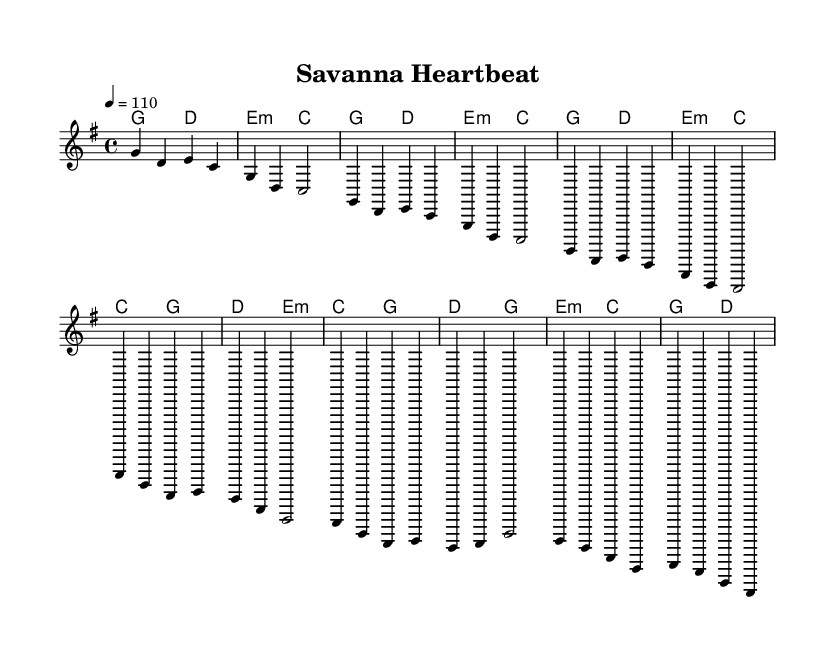What is the key signature of this music? The key signature is G major, which has one sharp (F#).
Answer: G major What is the time signature of this music? The time signature is 4/4, indicating four beats per measure.
Answer: 4/4 What is the tempo marking of this piece? The tempo marking is 110 beats per minute, indicated by the number under the tempo command.
Answer: 110 Which chord occurs most frequently in the harmonies? By analyzing the harmony section, G major appears at the start of multiple measures, making it prominent.
Answer: G major How many measures does the chorus section contain? The chorus consists of four measures, as indicated by the grouping of the chords and melody lines provided in the sheet music.
Answer: Four measures What rhythmic element is characteristic of Country Rock in this piece? The consistent use of quarter notes combined with a steady 4/4 beat reflects a typical rhythmic style of Country Rock.
Answer: Quarter notes What African rhythmic element is reflected in the melody? The syncopated feeling in certain melody sections suggests an African rhythmic influence, as seen in the varied note lengths.
Answer: Syncopation 